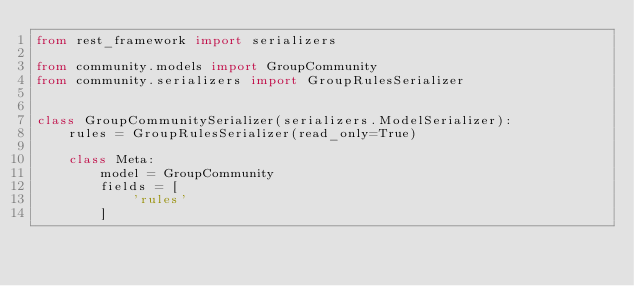<code> <loc_0><loc_0><loc_500><loc_500><_Python_>from rest_framework import serializers

from community.models import GroupCommunity
from community.serializers import GroupRulesSerializer


class GroupCommunitySerializer(serializers.ModelSerializer):
    rules = GroupRulesSerializer(read_only=True)

    class Meta:
        model = GroupCommunity
        fields = [
            'rules'
        ]
</code> 